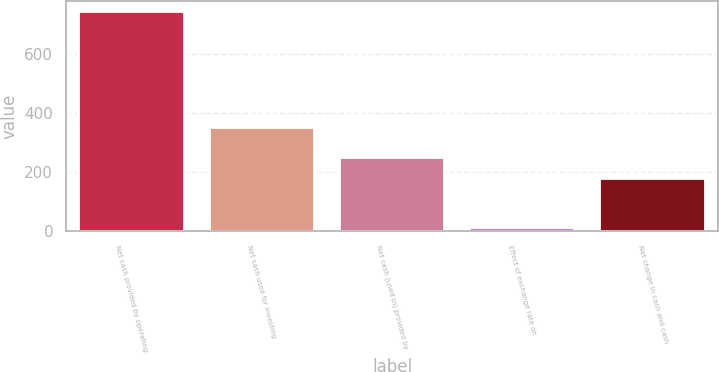Convert chart. <chart><loc_0><loc_0><loc_500><loc_500><bar_chart><fcel>Net cash provided by operating<fcel>Net cash used for investing<fcel>Net cash (used in) provided by<fcel>Effect of exchange rate on<fcel>Net change in cash and cash<nl><fcel>739<fcel>350.1<fcel>248.67<fcel>12.3<fcel>176<nl></chart> 